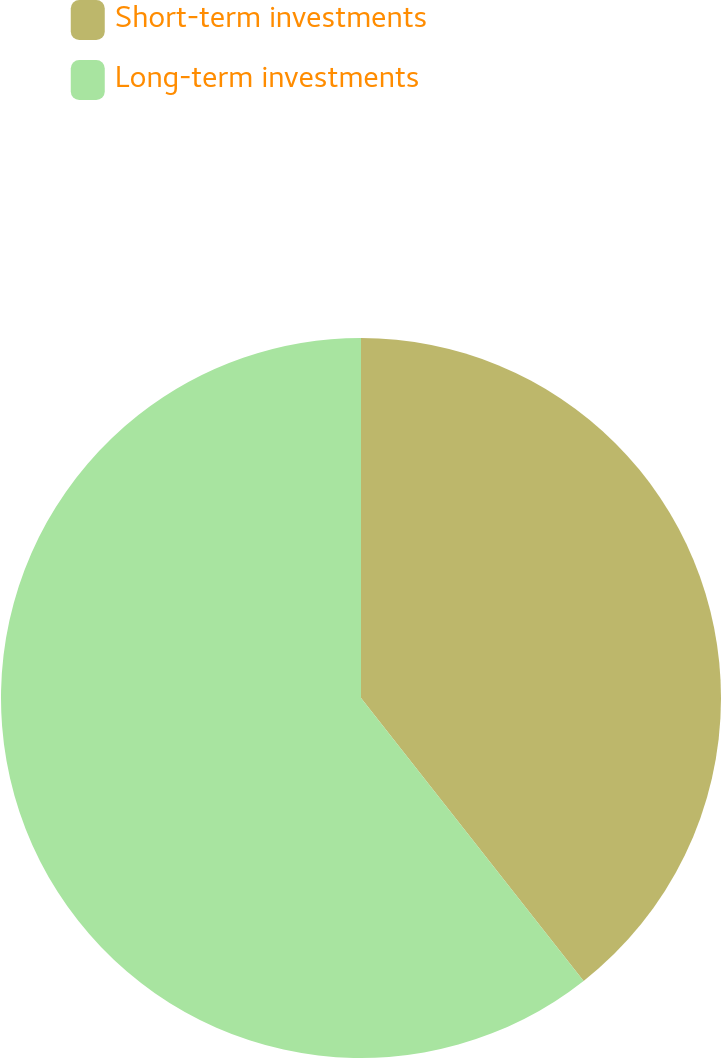Convert chart. <chart><loc_0><loc_0><loc_500><loc_500><pie_chart><fcel>Short-term investments<fcel>Long-term investments<nl><fcel>39.39%<fcel>60.61%<nl></chart> 